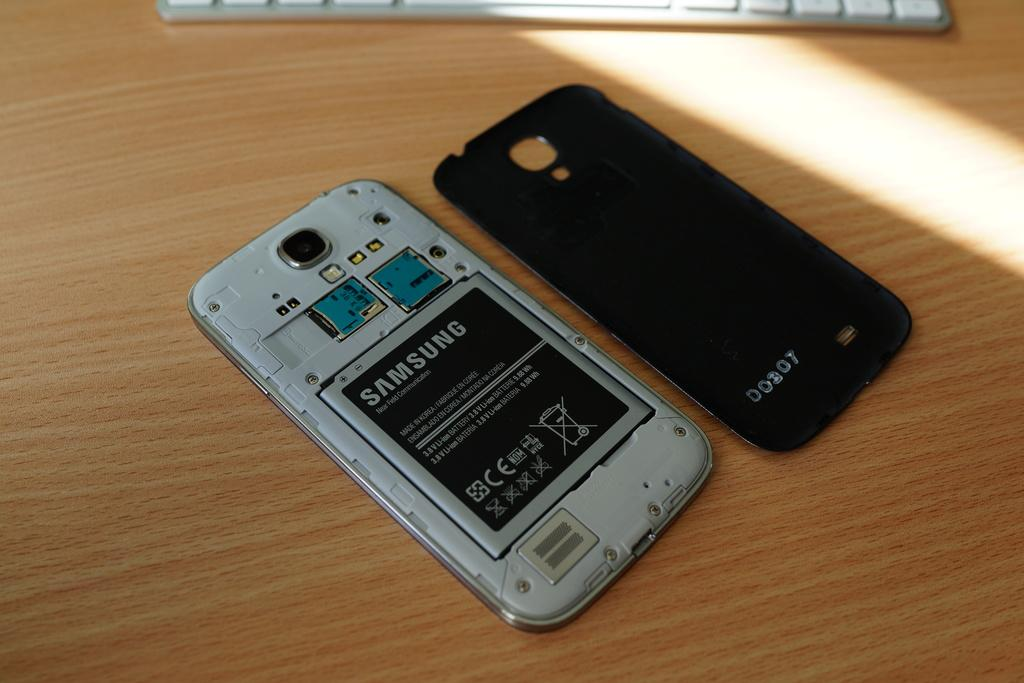<image>
Describe the image concisely. The back of a Samsung phone with the back plate removed and sitting next to it. 